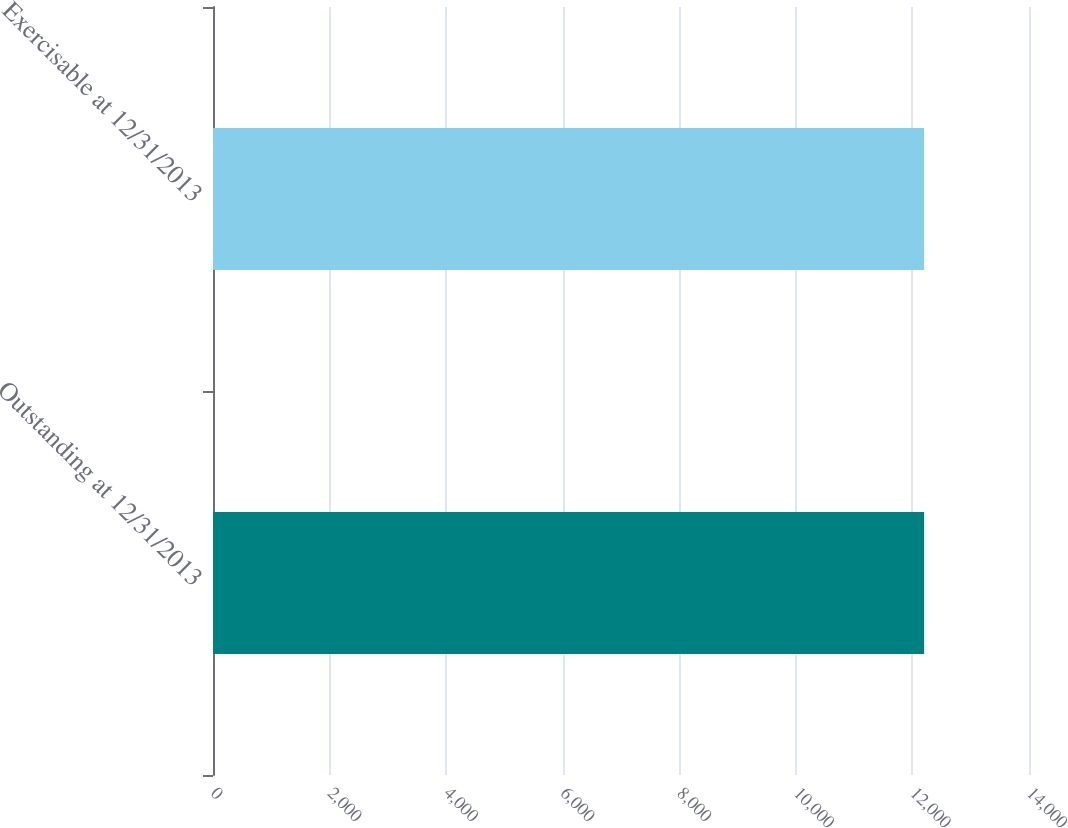<chart> <loc_0><loc_0><loc_500><loc_500><bar_chart><fcel>Outstanding at 12/31/2013<fcel>Exercisable at 12/31/2013<nl><fcel>12201<fcel>12201.1<nl></chart> 